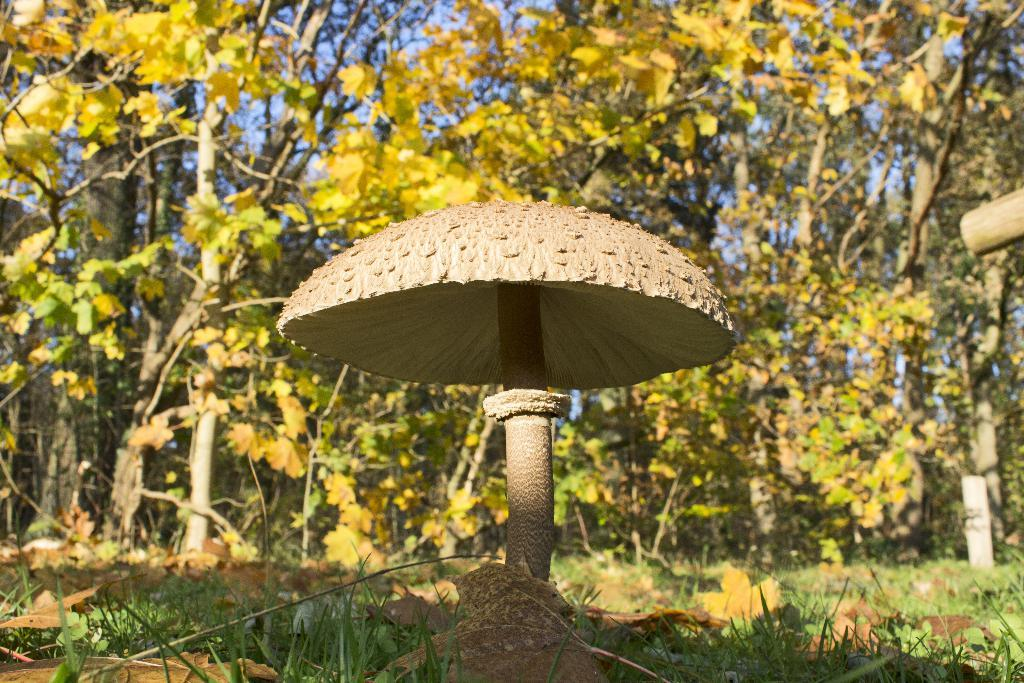What can be seen in the foreground of the picture? In the foreground of the picture, there are dry leaves, grass, and a mushroom. What type of vegetation is present in the foreground? The vegetation in the foreground includes dry leaves and grass. What is located in the foreground along with the vegetation? There is a mushroom in the foreground of the picture. What can be seen in the background of the picture? In the background of the picture, there are trees. How would you describe the weather in the image? The sky is sunny, indicating a clear and likely warm day. Where is your aunt sitting in the picture? There is no person, let alone an aunt, present in the image. What type of powder is sprinkled on the mushroom in the picture? There is no powder on the mushroom in the image; it is a natural mushroom in its original state. 